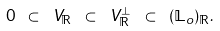<formula> <loc_0><loc_0><loc_500><loc_500>0 \ \subset \ V _ { \mathbb { R } } \ \subset \ V _ { \mathbb { R } } ^ { \perp } \ \subset \ ( \mathbb { L } _ { o } ) _ { \mathbb { R } } .</formula> 